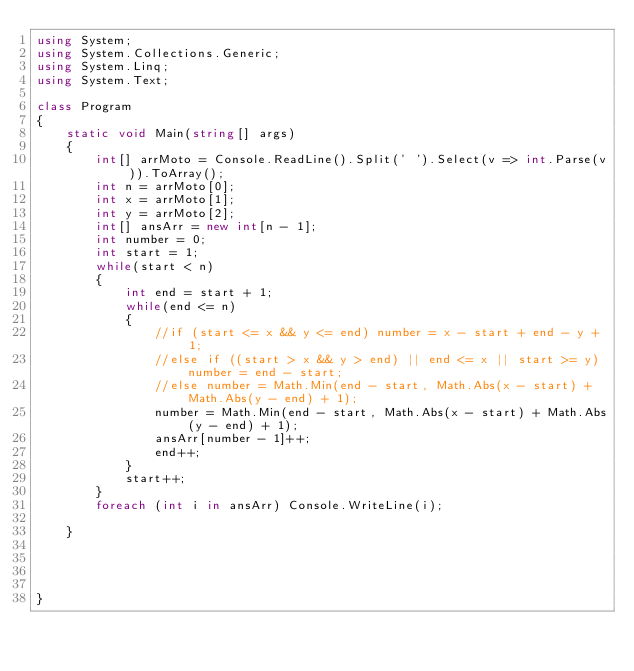<code> <loc_0><loc_0><loc_500><loc_500><_C#_>using System;
using System.Collections.Generic;
using System.Linq;
using System.Text;

class Program
{
    static void Main(string[] args)
    {
        int[] arrMoto = Console.ReadLine().Split(' ').Select(v => int.Parse(v)).ToArray();
        int n = arrMoto[0];
        int x = arrMoto[1];
        int y = arrMoto[2];
        int[] ansArr = new int[n - 1];
        int number = 0;
        int start = 1;
        while(start < n)
        {
            int end = start + 1;
            while(end <= n)
            {
                //if (start <= x && y <= end) number = x - start + end - y + 1;
                //else if ((start > x && y > end) || end <= x || start >= y) number = end - start;
                //else number = Math.Min(end - start, Math.Abs(x - start) + Math.Abs(y - end) + 1);    
                number = Math.Min(end - start, Math.Abs(x - start) + Math.Abs(y - end) + 1);
                ansArr[number - 1]++;
                end++;
            }
            start++;
        }
        foreach (int i in ansArr) Console.WriteLine(i);

    }


  

}

</code> 